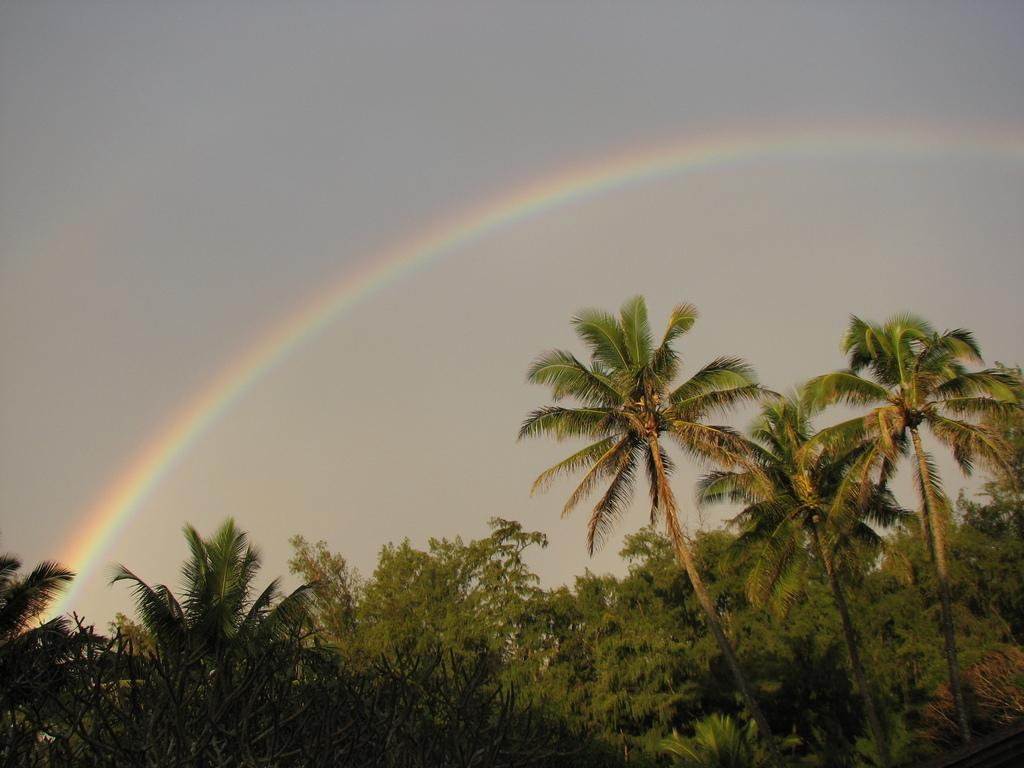What type of vegetation is visible in the image? There are trees in the image. What is visible at the top of the image? The sky is visible at the top of the image. What natural phenomenon can be seen in the image? There is a rainbow in the image. Can you tell me how many trucks are visible in the image? There are no trucks present in the image. What type of material is the zephyr made of in the image? There is no zephyr present in the image, and therefore no such material can be observed. 